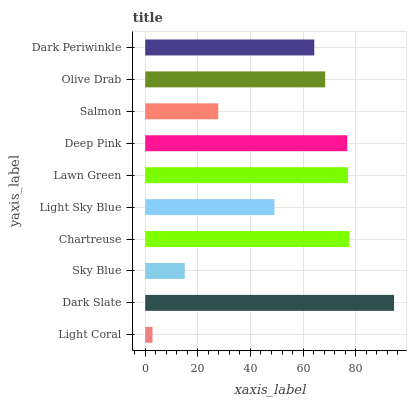Is Light Coral the minimum?
Answer yes or no. Yes. Is Dark Slate the maximum?
Answer yes or no. Yes. Is Sky Blue the minimum?
Answer yes or no. No. Is Sky Blue the maximum?
Answer yes or no. No. Is Dark Slate greater than Sky Blue?
Answer yes or no. Yes. Is Sky Blue less than Dark Slate?
Answer yes or no. Yes. Is Sky Blue greater than Dark Slate?
Answer yes or no. No. Is Dark Slate less than Sky Blue?
Answer yes or no. No. Is Olive Drab the high median?
Answer yes or no. Yes. Is Dark Periwinkle the low median?
Answer yes or no. Yes. Is Dark Periwinkle the high median?
Answer yes or no. No. Is Light Sky Blue the low median?
Answer yes or no. No. 